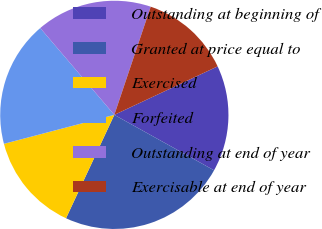<chart> <loc_0><loc_0><loc_500><loc_500><pie_chart><fcel>Outstanding at beginning of<fcel>Granted at price equal to<fcel>Exercised<fcel>Forfeited<fcel>Outstanding at end of year<fcel>Exercisable at end of year<nl><fcel>15.06%<fcel>23.88%<fcel>13.96%<fcel>17.84%<fcel>16.41%<fcel>12.85%<nl></chart> 